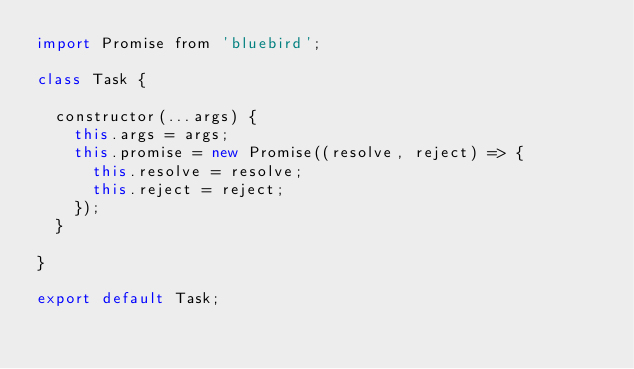<code> <loc_0><loc_0><loc_500><loc_500><_JavaScript_>import Promise from 'bluebird';

class Task {

  constructor(...args) {
    this.args = args;
    this.promise = new Promise((resolve, reject) => {
      this.resolve = resolve;
      this.reject = reject;
    });
  }

}

export default Task;
</code> 